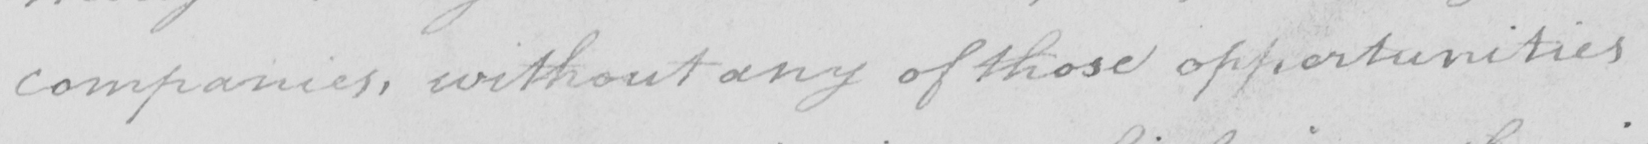Transcribe the text shown in this historical manuscript line. companies , without any of those opportunities 